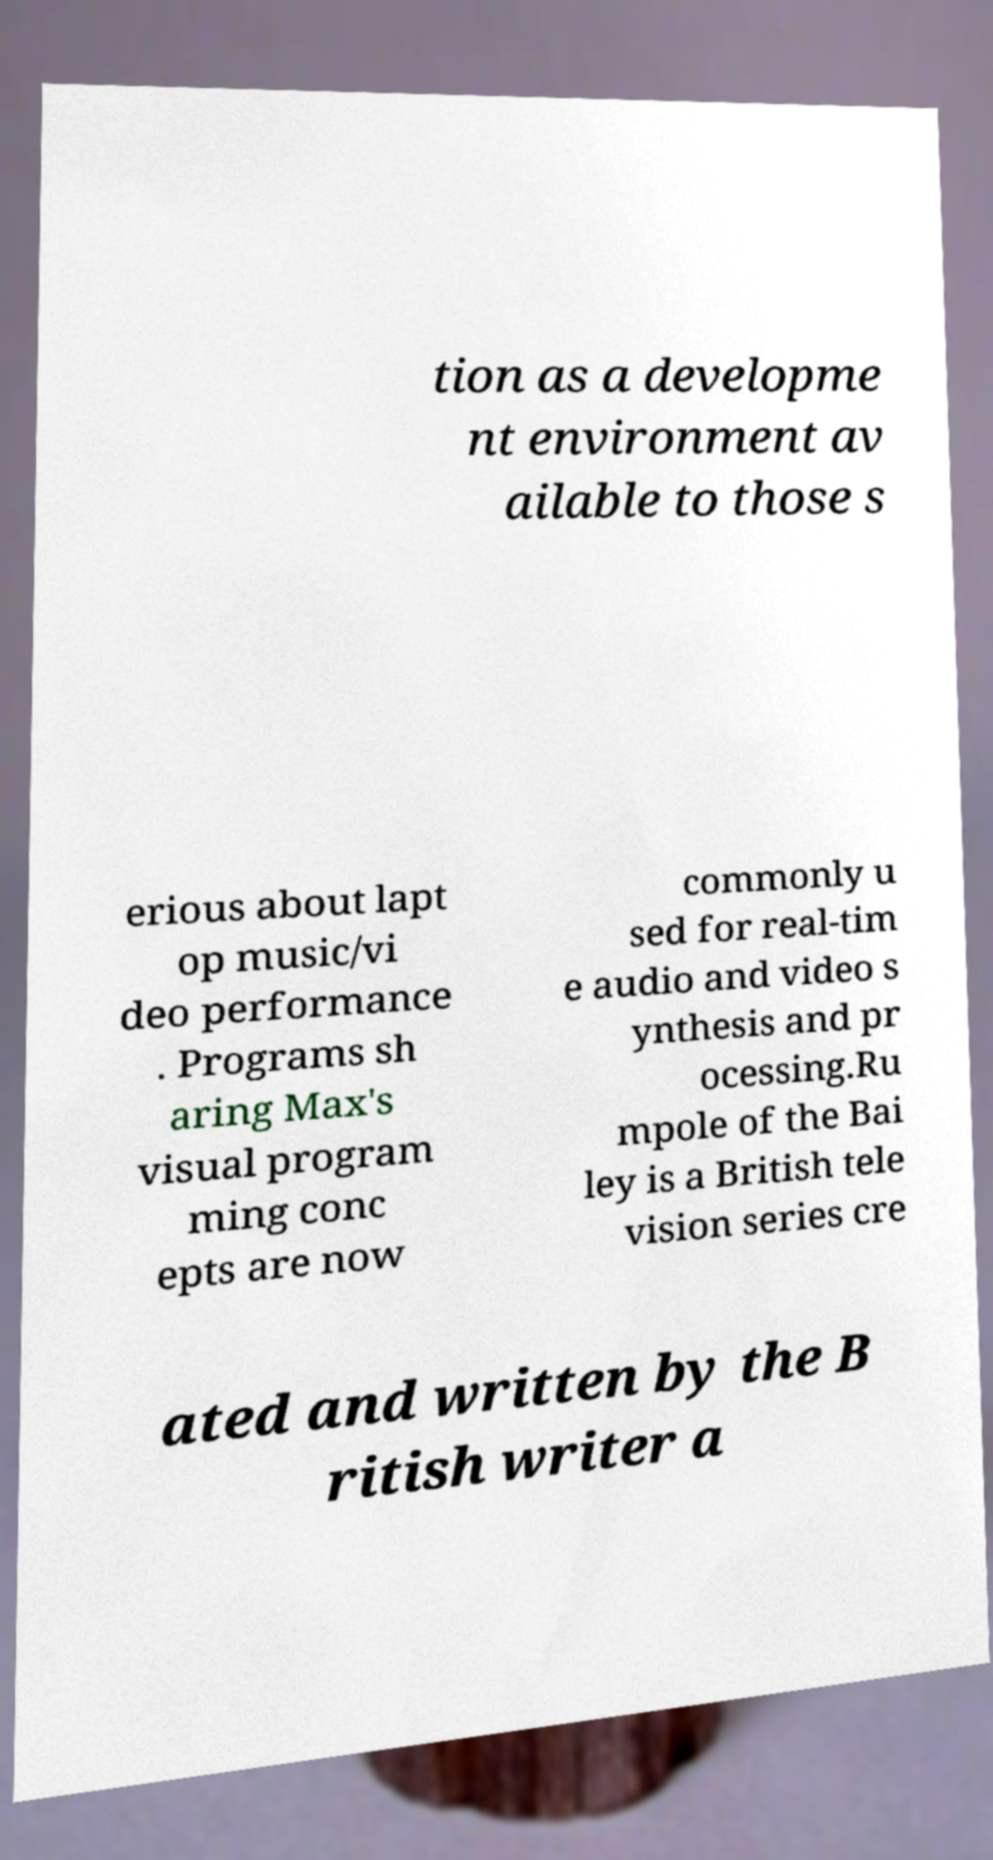Can you read and provide the text displayed in the image?This photo seems to have some interesting text. Can you extract and type it out for me? tion as a developme nt environment av ailable to those s erious about lapt op music/vi deo performance . Programs sh aring Max's visual program ming conc epts are now commonly u sed for real-tim e audio and video s ynthesis and pr ocessing.Ru mpole of the Bai ley is a British tele vision series cre ated and written by the B ritish writer a 